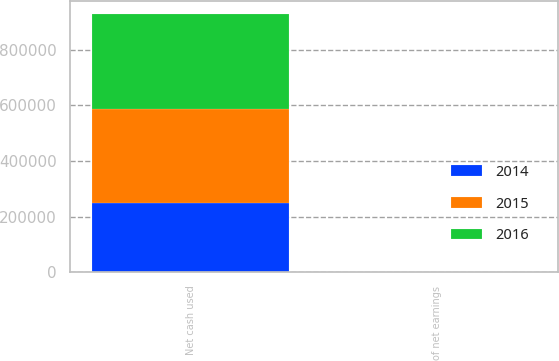Convert chart to OTSL. <chart><loc_0><loc_0><loc_500><loc_500><stacked_bar_chart><ecel><fcel>Net cash used<fcel>of net earnings<nl><fcel>2016<fcel>340872<fcel>68.2<nl><fcel>2015<fcel>337563<fcel>65.4<nl><fcel>2014<fcel>249732<fcel>50.5<nl></chart> 